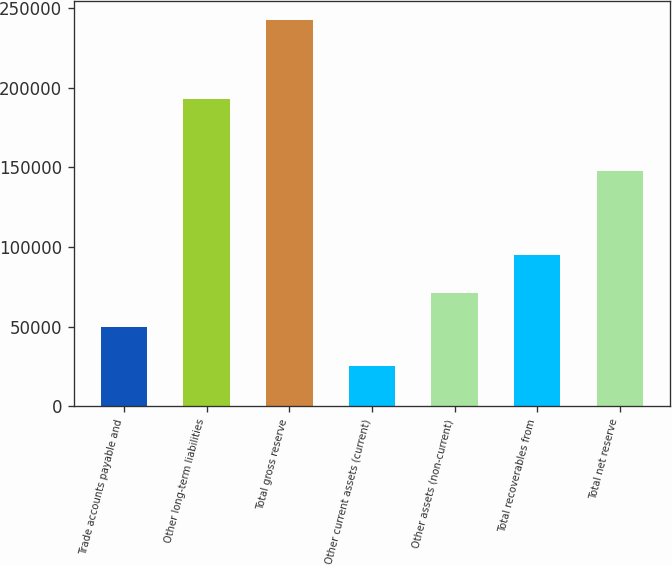Convert chart to OTSL. <chart><loc_0><loc_0><loc_500><loc_500><bar_chart><fcel>Trade accounts payable and<fcel>Other long-term liabilities<fcel>Total gross reserve<fcel>Other current assets (current)<fcel>Other assets (non-current)<fcel>Total recoverables from<fcel>Total net reserve<nl><fcel>49594<fcel>192922<fcel>242516<fcel>25248<fcel>71320.8<fcel>95008<fcel>147508<nl></chart> 